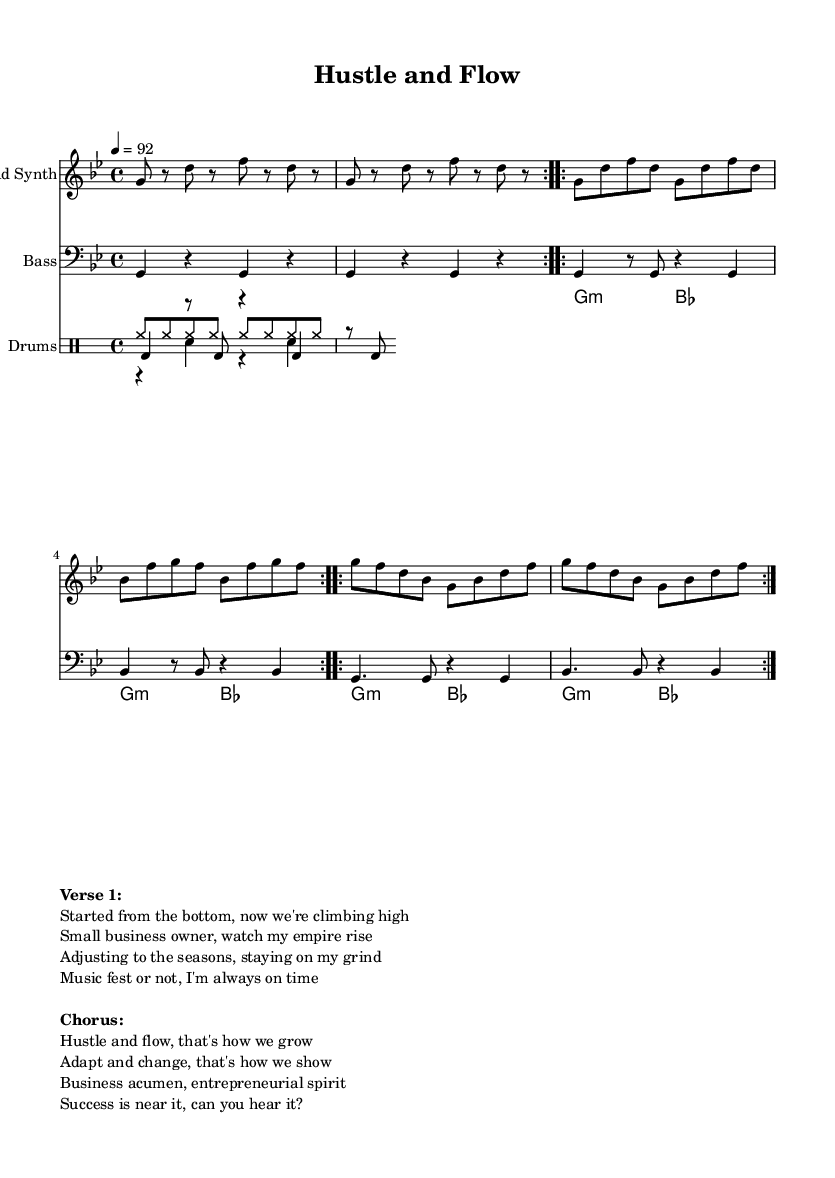What is the key signature of this music? The key signature is G minor, indicated by the presence of two flats (B♭ and E♭). This can be determined by observing the key signature section of the sheet music.
Answer: G minor What is the time signature of this composition? The time signature is 4/4, as specified right at the beginning of the global settings in the sheet music. This means there are four beats in a measure, and the quarter note gets one beat.
Answer: 4/4 What is the tempo marking for this track? The tempo marking is 92 beats per minute, indicated by the notation "4 = 92." This tells the performer to play the music at this speed.
Answer: 92 How many volte do you see repeated in the lead synth section? The lead synth section contains a total of 6 volta markings, as it indicates three repeated sections, each marked with "volta" twice. To confirm, one can count the number of "repeat volta" phrases.
Answer: 6 What is the title of this piece? The title is given in the header of the sheet music as "Hustle and Flow." It is typically found at the top of the arrangement.
Answer: Hustle and Flow What is the primary theme conveyed in the lyrics? The primary theme conveyed is entrepreneurship and hustle, focusing on personal growth and adapting to change as a small business owner. This can be gathered by reading the lyrics present in the markup section.
Answer: Entrepreneurship What instruments are featured in this arrangement? The arrangement features a lead synth, bass, and drums. Each is identified in the score under their respective staff labels. There’s explicit labeling of each staff with the respective instrument names.
Answer: Lead Synth, Bass, Drums 